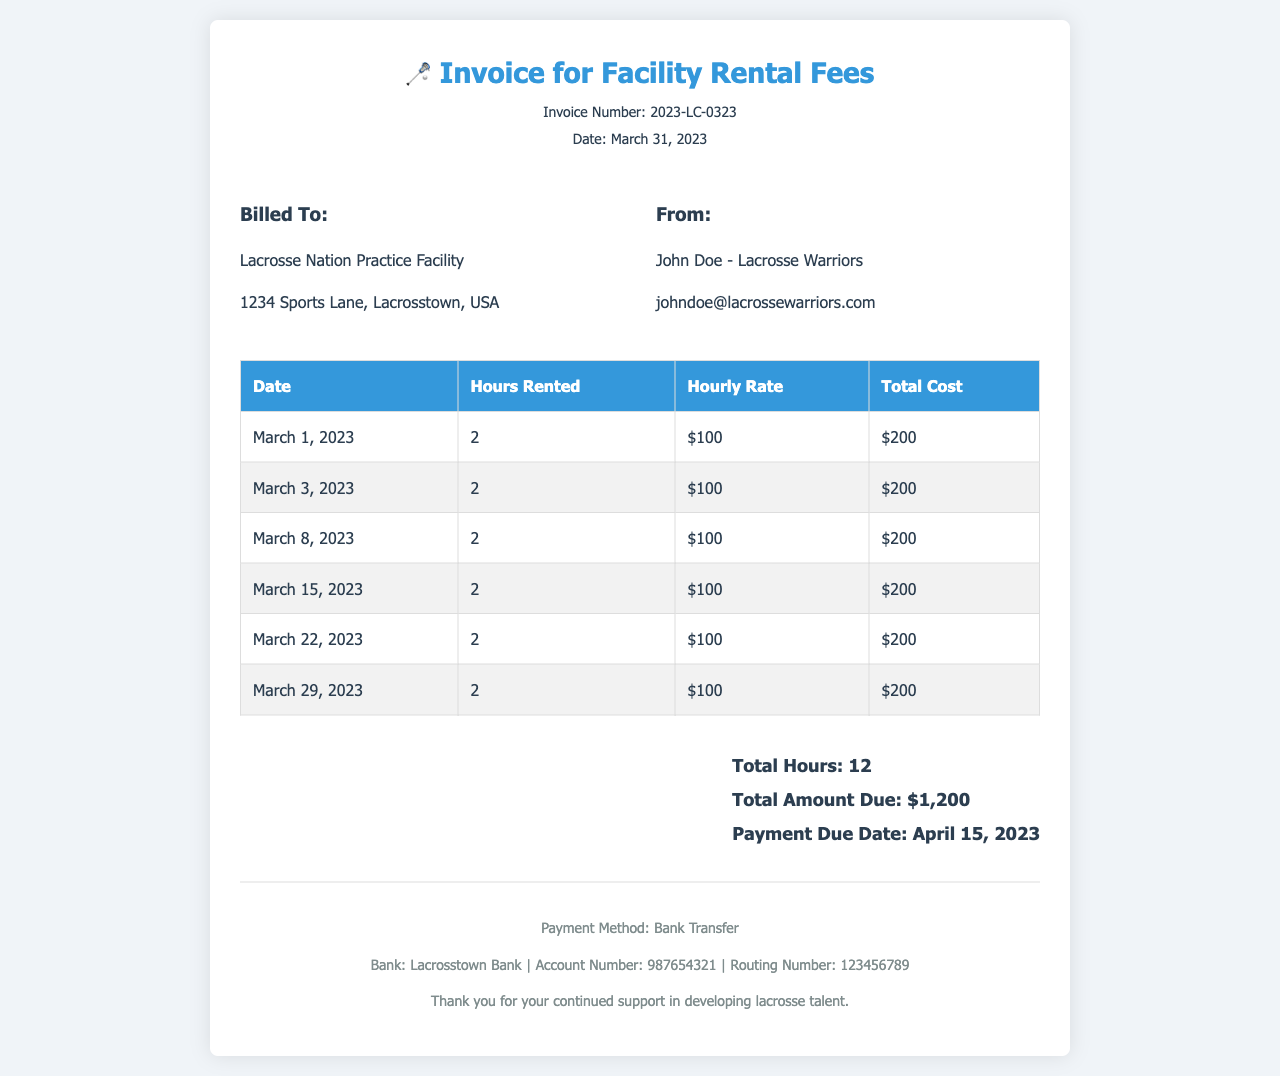What is the invoice number? The invoice number can be found at the top of the document, which is 2023-LC-0323.
Answer: 2023-LC-0323 What is the total amount due? The total amount due is stated in the summary section of the document, which is $1,200.
Answer: $1,200 When is the payment due date? The payment due date is mentioned in the summary section of the invoice as April 15, 2023.
Answer: April 15, 2023 How many hours were rented in total? The total hours rented can be found in the summary of the document, which states 12 hours.
Answer: 12 What is the hourly rate? The hourly rate is consistently listed for each session, which is $100.
Answer: $100 What facility is being billed? The facility being billed is Lacrosse Nation Practice Facility, mentioned in the billing info section.
Answer: Lacrosse Nation Practice Facility How many practice sessions were held in March? The document lists six practice sessions under the dates and hours rented section.
Answer: 6 What is the name of the person the invoice is from? The person's name is listed in the billing information as John Doe.
Answer: John Doe What type of payment method is specified? The payment method is stated at the footer of the invoice as Bank Transfer.
Answer: Bank Transfer 